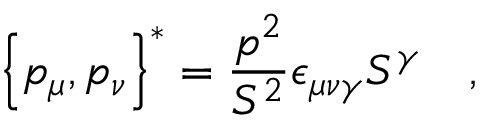<formula> <loc_0><loc_0><loc_500><loc_500>\left \{ p _ { \mu } , p _ { \nu } \right \} ^ { * } = \frac { p ^ { 2 } } { S ^ { 2 } } \epsilon _ { \mu \nu \gamma } S ^ { \gamma } \quad ,</formula> 